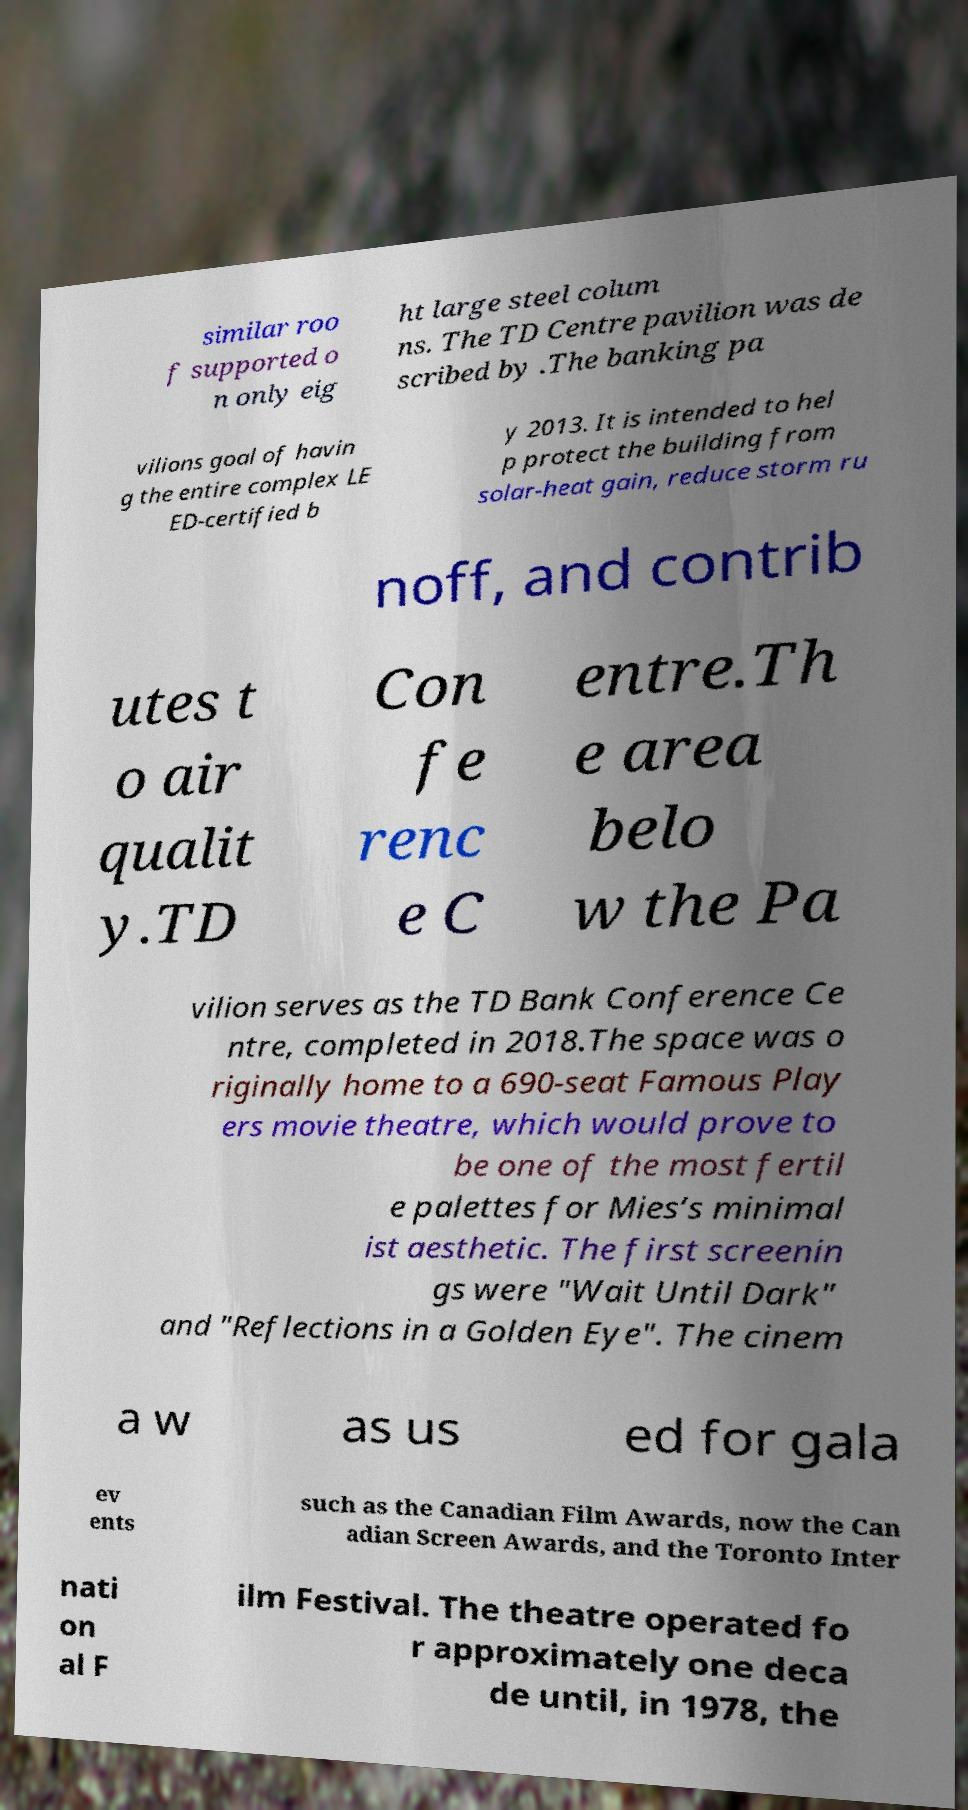What messages or text are displayed in this image? I need them in a readable, typed format. similar roo f supported o n only eig ht large steel colum ns. The TD Centre pavilion was de scribed by .The banking pa vilions goal of havin g the entire complex LE ED-certified b y 2013. It is intended to hel p protect the building from solar-heat gain, reduce storm ru noff, and contrib utes t o air qualit y.TD Con fe renc e C entre.Th e area belo w the Pa vilion serves as the TD Bank Conference Ce ntre, completed in 2018.The space was o riginally home to a 690-seat Famous Play ers movie theatre, which would prove to be one of the most fertil e palettes for Mies’s minimal ist aesthetic. The first screenin gs were "Wait Until Dark" and "Reflections in a Golden Eye". The cinem a w as us ed for gala ev ents such as the Canadian Film Awards, now the Can adian Screen Awards, and the Toronto Inter nati on al F ilm Festival. The theatre operated fo r approximately one deca de until, in 1978, the 